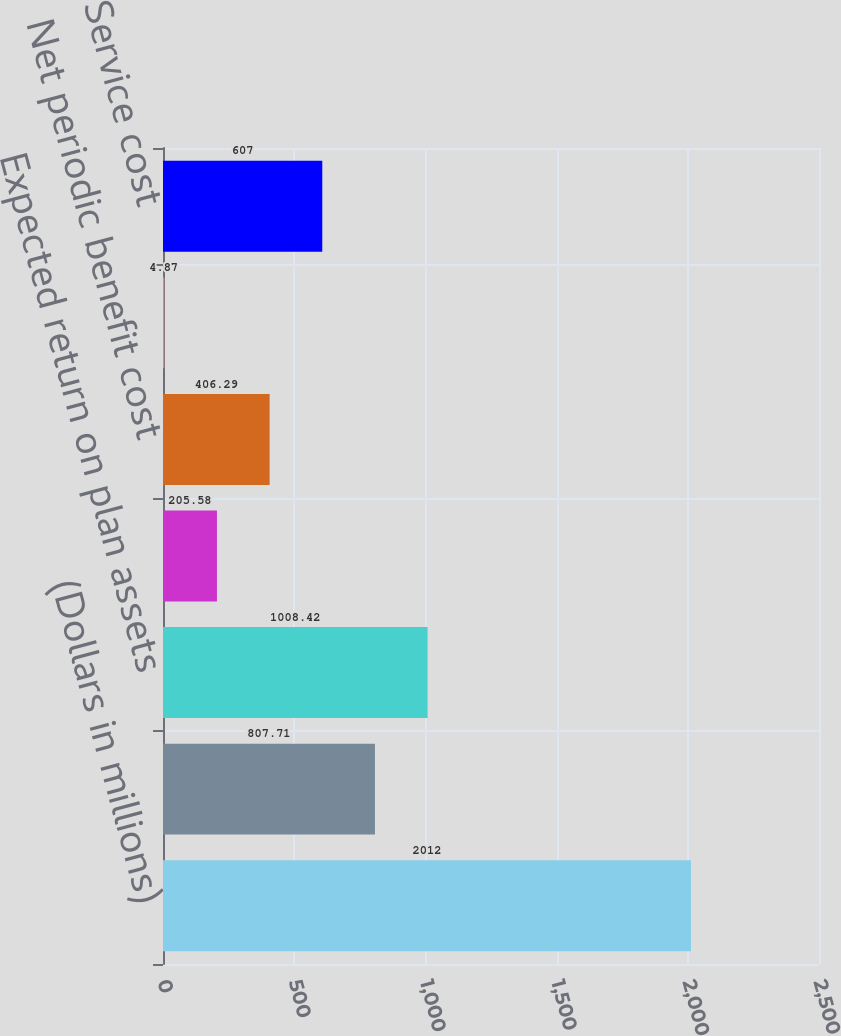Convert chart. <chart><loc_0><loc_0><loc_500><loc_500><bar_chart><fcel>(Dollars in millions)<fcel>Interest cost<fcel>Expected return on plan assets<fcel>Amortization of net actuarial<fcel>Net periodic benefit cost<fcel>Discount rate<fcel>Service cost<nl><fcel>2012<fcel>807.71<fcel>1008.42<fcel>205.58<fcel>406.29<fcel>4.87<fcel>607<nl></chart> 